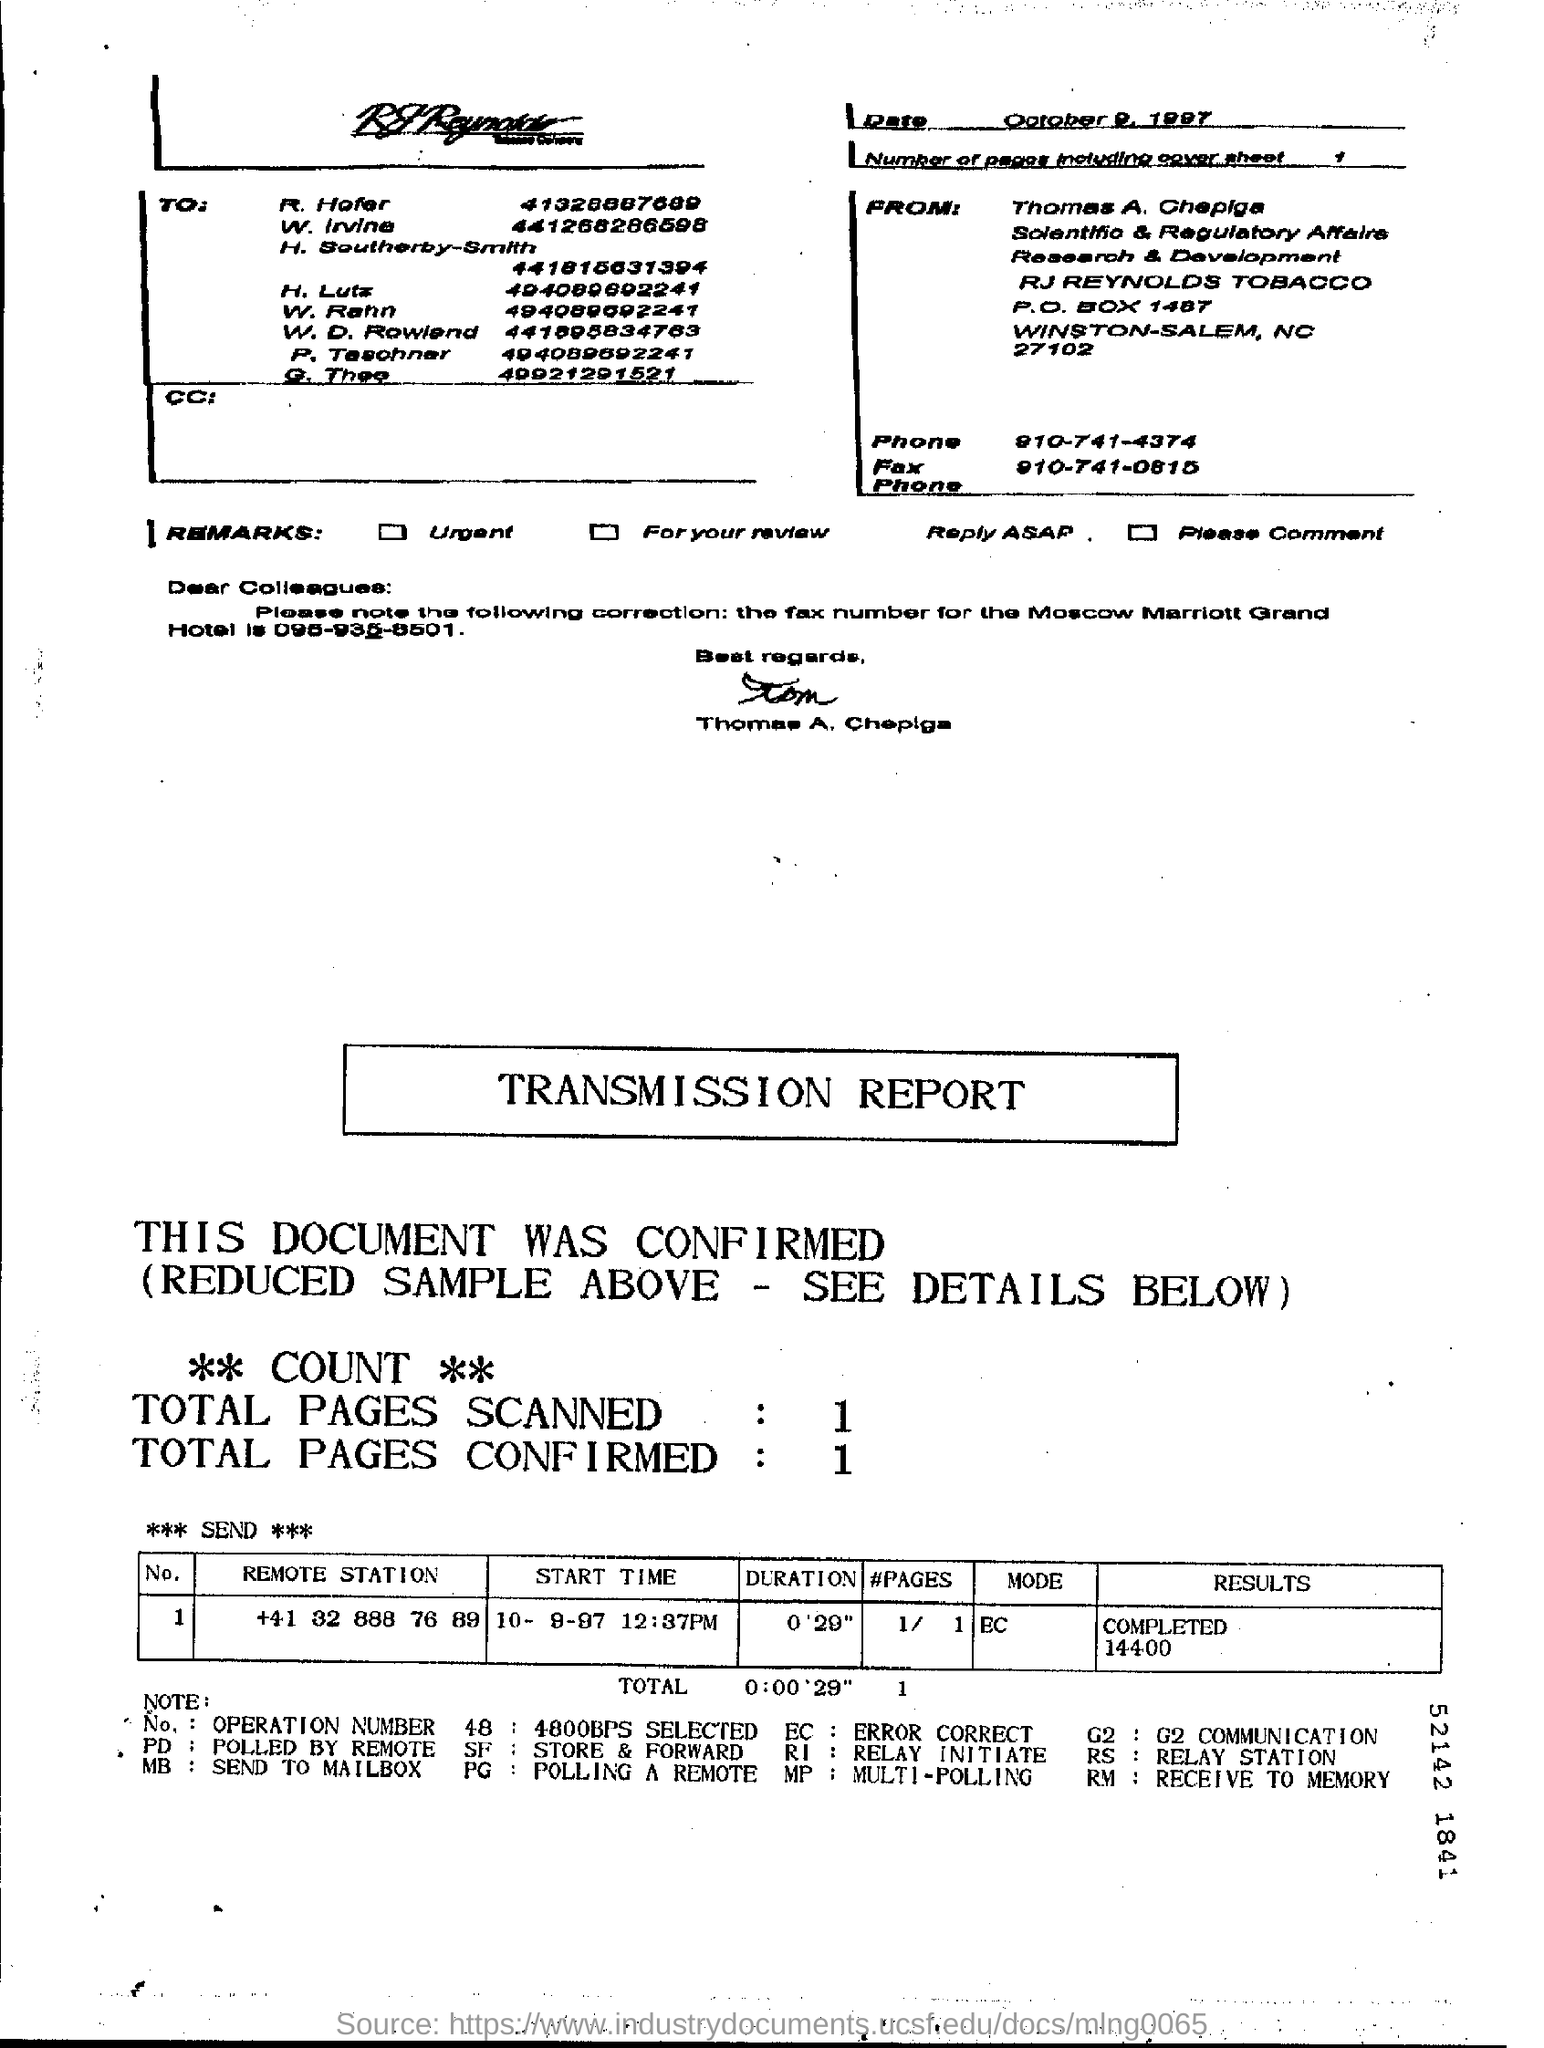WHAT IS THE PHONE NUMBER OF THOMAS A. CHAPIGA?
Offer a terse response. 910-741-4374. 